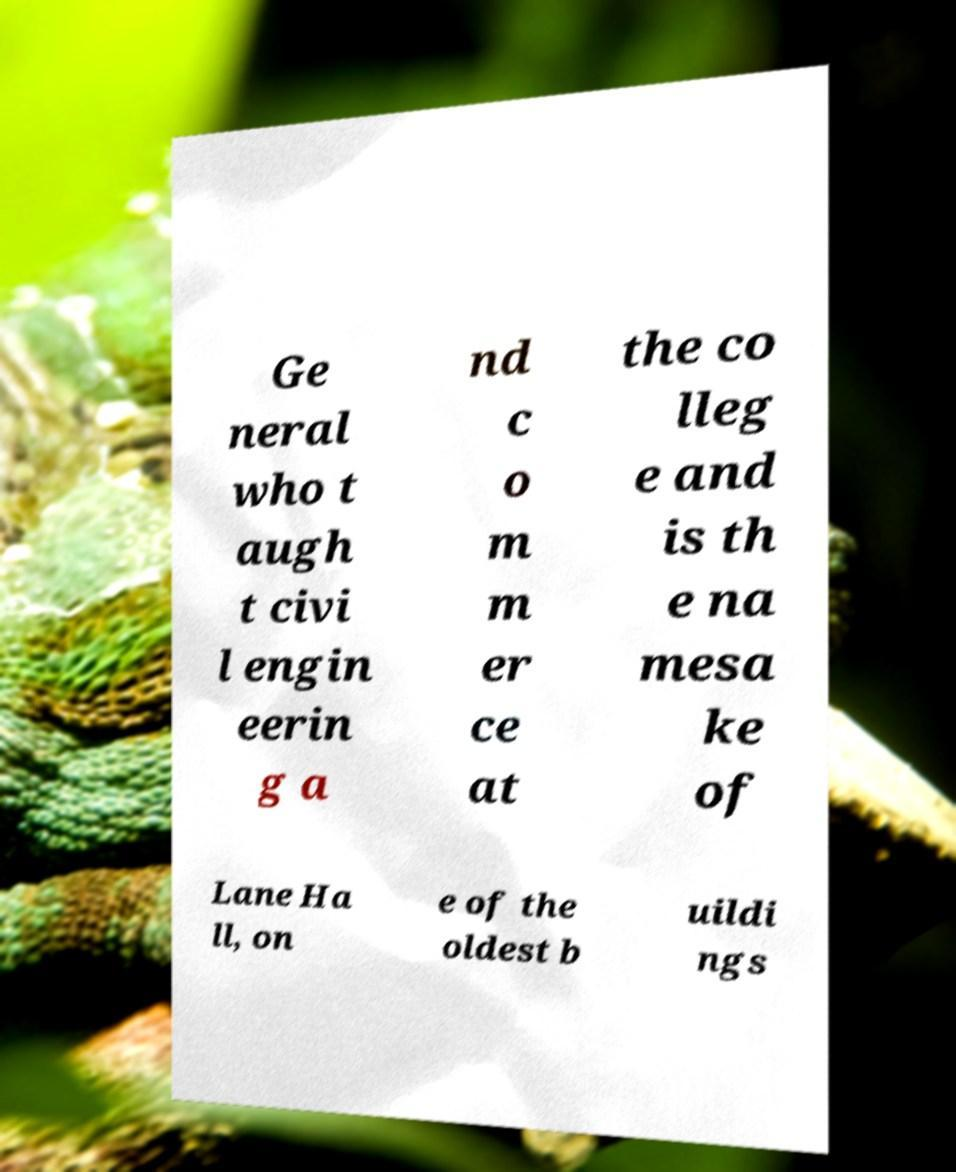Please read and relay the text visible in this image. What does it say? Ge neral who t augh t civi l engin eerin g a nd c o m m er ce at the co lleg e and is th e na mesa ke of Lane Ha ll, on e of the oldest b uildi ngs 